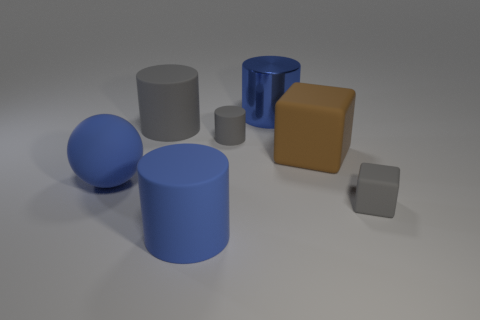Add 2 big gray matte cylinders. How many objects exist? 9 Subtract all cylinders. How many objects are left? 3 Subtract all matte cubes. Subtract all blue rubber things. How many objects are left? 3 Add 4 rubber cylinders. How many rubber cylinders are left? 7 Add 2 small green cylinders. How many small green cylinders exist? 2 Subtract 0 purple blocks. How many objects are left? 7 